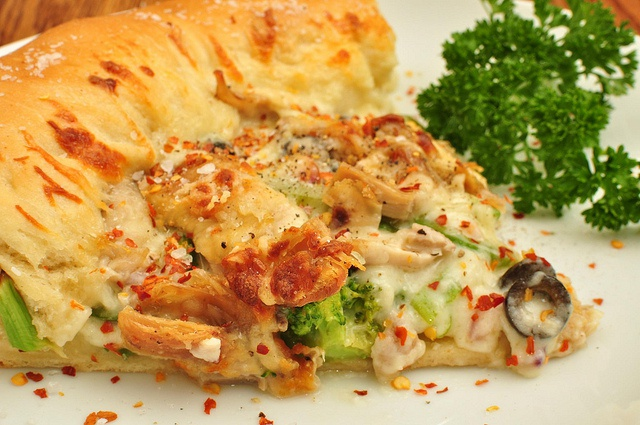Describe the objects in this image and their specific colors. I can see pizza in brown, orange, gold, and red tones, broccoli in brown, darkgreen, and olive tones, and broccoli in brown, olive, and black tones in this image. 